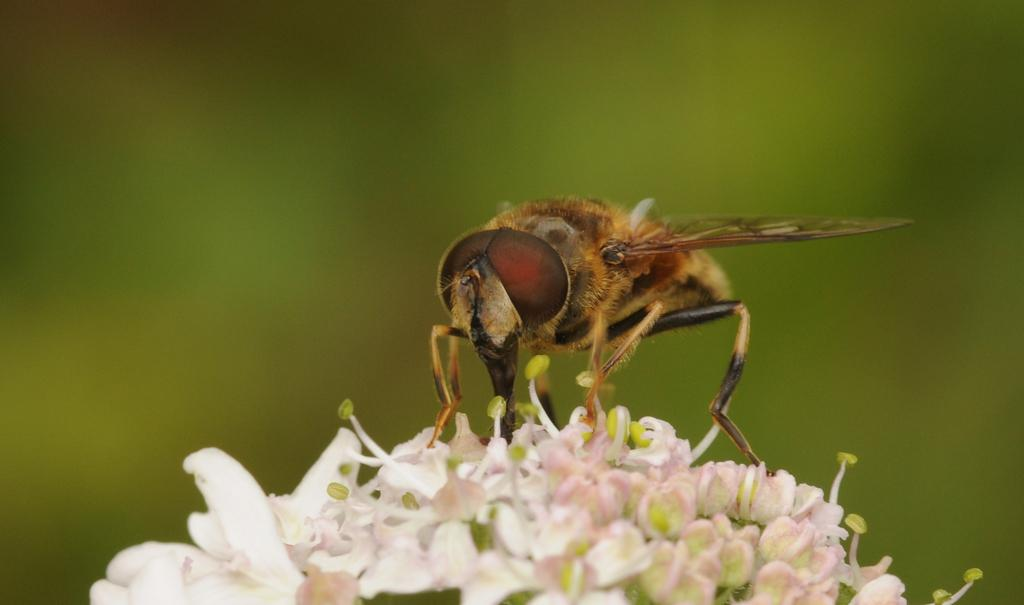What is present in the image? There is a fly in the image. Where is the fly located? The fly is on a flower. What type of beef is being served at the governor's invention event in the image? There is no beef, governor, or invention event present in the image; it only features a fly on a flower. 